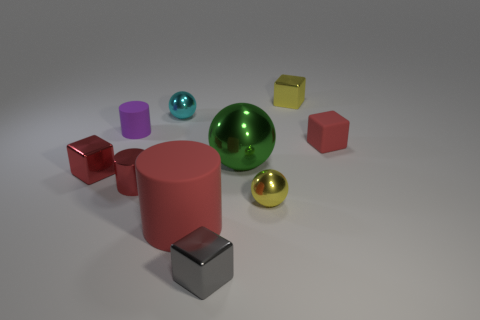Subtract all metal blocks. How many blocks are left? 1 Subtract all gray cubes. How many cubes are left? 3 Subtract 0 blue spheres. How many objects are left? 10 Subtract all cubes. How many objects are left? 6 Subtract 2 blocks. How many blocks are left? 2 Subtract all purple spheres. Subtract all blue blocks. How many spheres are left? 3 Subtract all gray blocks. How many red spheres are left? 0 Subtract all red things. Subtract all purple matte cylinders. How many objects are left? 5 Add 3 tiny red shiny cylinders. How many tiny red shiny cylinders are left? 4 Add 6 big red rubber objects. How many big red rubber objects exist? 7 